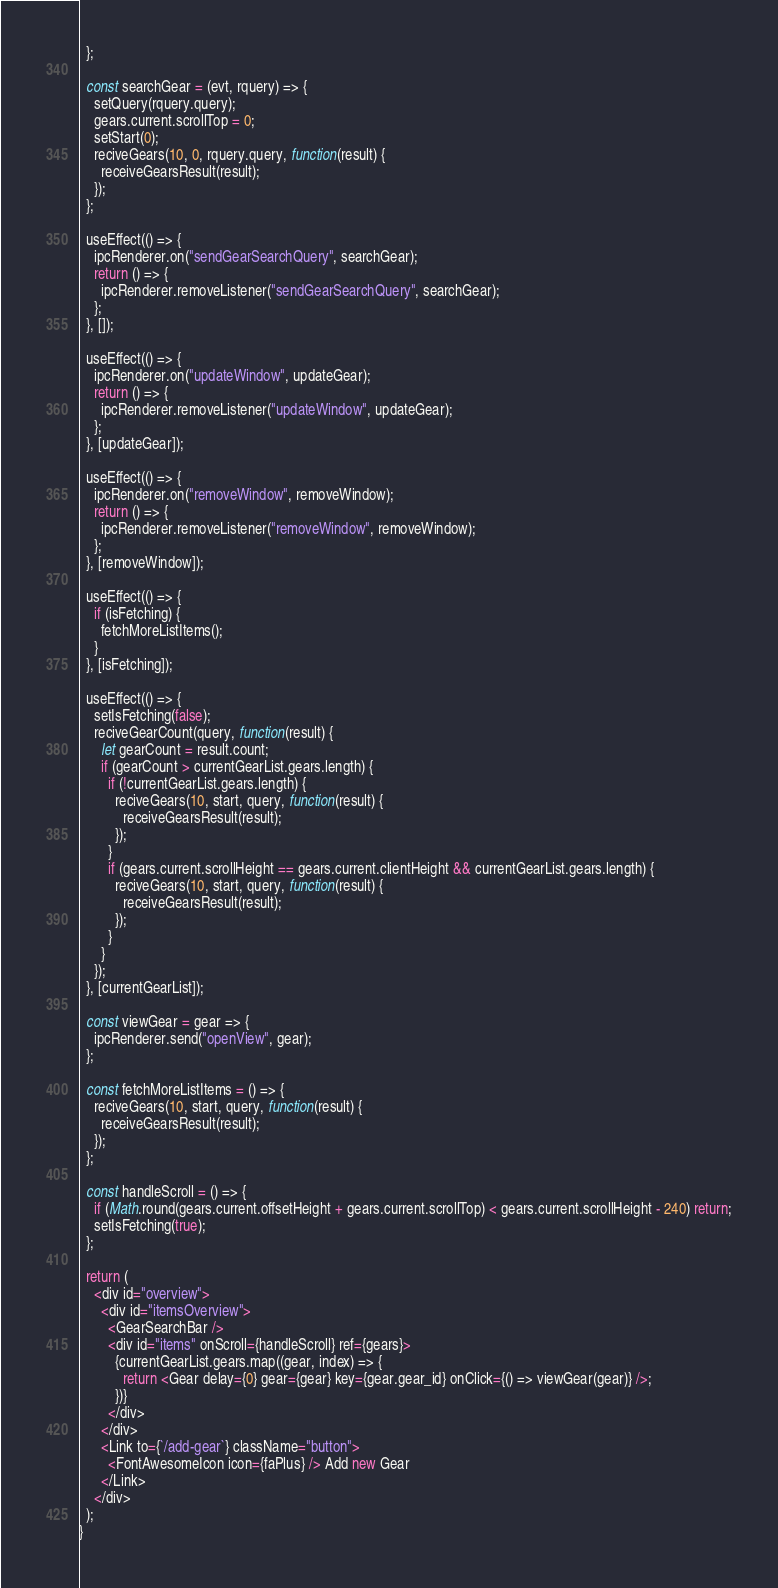Convert code to text. <code><loc_0><loc_0><loc_500><loc_500><_JavaScript_>  };

  const searchGear = (evt, rquery) => {
    setQuery(rquery.query);
    gears.current.scrollTop = 0;
    setStart(0);
    reciveGears(10, 0, rquery.query, function(result) {
      receiveGearsResult(result);
    });
  };

  useEffect(() => {
    ipcRenderer.on("sendGearSearchQuery", searchGear);
    return () => {
      ipcRenderer.removeListener("sendGearSearchQuery", searchGear);
    };
  }, []);

  useEffect(() => {
    ipcRenderer.on("updateWindow", updateGear);
    return () => {
      ipcRenderer.removeListener("updateWindow", updateGear);
    };
  }, [updateGear]);

  useEffect(() => {
    ipcRenderer.on("removeWindow", removeWindow);
    return () => {
      ipcRenderer.removeListener("removeWindow", removeWindow);
    };
  }, [removeWindow]);

  useEffect(() => {
    if (isFetching) {
      fetchMoreListItems();
    }
  }, [isFetching]);

  useEffect(() => {
    setIsFetching(false);
    reciveGearCount(query, function(result) {
      let gearCount = result.count;
      if (gearCount > currentGearList.gears.length) {
        if (!currentGearList.gears.length) {
          reciveGears(10, start, query, function(result) {
            receiveGearsResult(result);
          });
        }
        if (gears.current.scrollHeight == gears.current.clientHeight && currentGearList.gears.length) {
          reciveGears(10, start, query, function(result) {
            receiveGearsResult(result);
          });
        }
      }
    });
  }, [currentGearList]);

  const viewGear = gear => {
    ipcRenderer.send("openView", gear);
  };

  const fetchMoreListItems = () => {
    reciveGears(10, start, query, function(result) {
      receiveGearsResult(result);
    });
  };

  const handleScroll = () => {
    if (Math.round(gears.current.offsetHeight + gears.current.scrollTop) < gears.current.scrollHeight - 240) return;
    setIsFetching(true);
  };

  return (
    <div id="overview">
      <div id="itemsOverview">
        <GearSearchBar />
        <div id="items" onScroll={handleScroll} ref={gears}>
          {currentGearList.gears.map((gear, index) => {
            return <Gear delay={0} gear={gear} key={gear.gear_id} onClick={() => viewGear(gear)} />;
          })}
        </div>
      </div>
      <Link to={`/add-gear`} className="button">
        <FontAwesomeIcon icon={faPlus} /> Add new Gear
      </Link>
    </div>
  );
}
</code> 